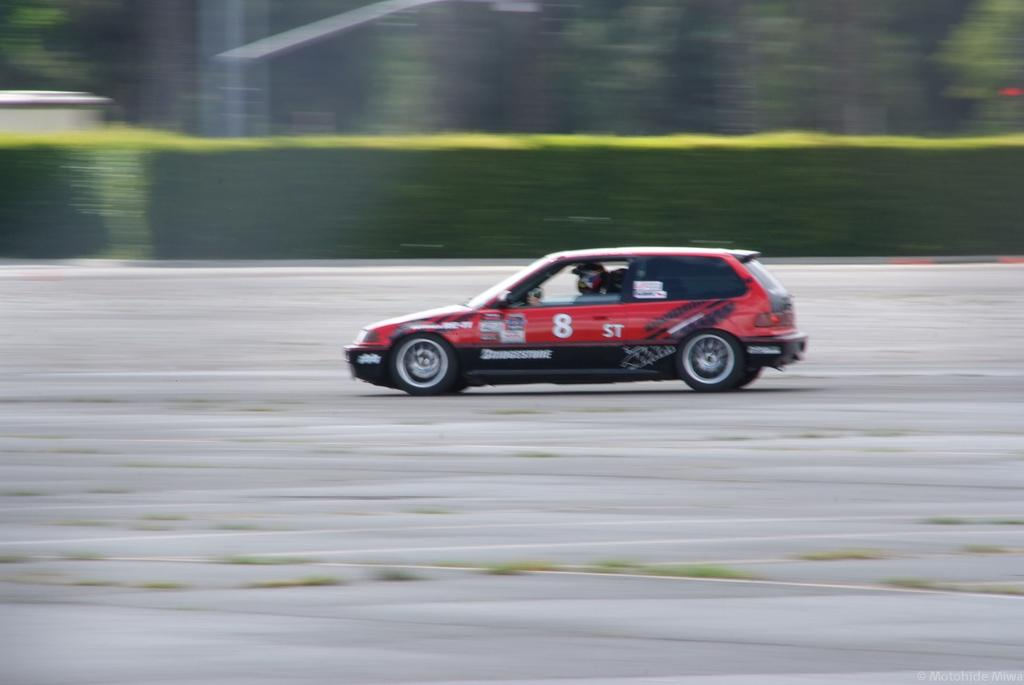What is the person in the image doing? There is a person driving a vehicle in the image. Where is the vehicle located? The vehicle is on the road. What can be seen in the background of the image? There are plants in the background of the image. How is the background of the image depicted? The background of the image is blurred. What type of sack is the person carrying while driving in the image? There is no sack visible in the image; the person is driving a vehicle. How does the person rest while driving in the image? The person is actively driving in the image and does not appear to be resting. 